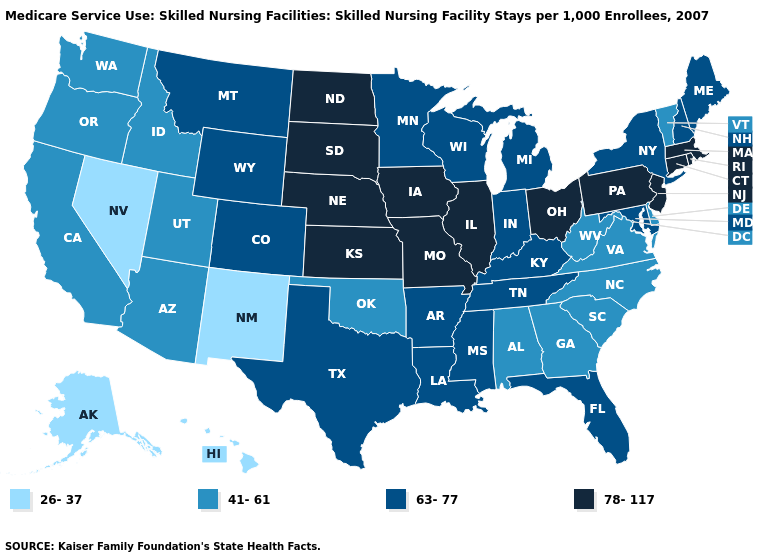Name the states that have a value in the range 41-61?
Short answer required. Alabama, Arizona, California, Delaware, Georgia, Idaho, North Carolina, Oklahoma, Oregon, South Carolina, Utah, Vermont, Virginia, Washington, West Virginia. Name the states that have a value in the range 63-77?
Keep it brief. Arkansas, Colorado, Florida, Indiana, Kentucky, Louisiana, Maine, Maryland, Michigan, Minnesota, Mississippi, Montana, New Hampshire, New York, Tennessee, Texas, Wisconsin, Wyoming. What is the highest value in the South ?
Quick response, please. 63-77. What is the value of Oklahoma?
Answer briefly. 41-61. Name the states that have a value in the range 41-61?
Quick response, please. Alabama, Arizona, California, Delaware, Georgia, Idaho, North Carolina, Oklahoma, Oregon, South Carolina, Utah, Vermont, Virginia, Washington, West Virginia. Does Texas have the same value as Tennessee?
Give a very brief answer. Yes. Name the states that have a value in the range 63-77?
Short answer required. Arkansas, Colorado, Florida, Indiana, Kentucky, Louisiana, Maine, Maryland, Michigan, Minnesota, Mississippi, Montana, New Hampshire, New York, Tennessee, Texas, Wisconsin, Wyoming. Name the states that have a value in the range 63-77?
Keep it brief. Arkansas, Colorado, Florida, Indiana, Kentucky, Louisiana, Maine, Maryland, Michigan, Minnesota, Mississippi, Montana, New Hampshire, New York, Tennessee, Texas, Wisconsin, Wyoming. What is the value of Michigan?
Concise answer only. 63-77. Name the states that have a value in the range 26-37?
Keep it brief. Alaska, Hawaii, Nevada, New Mexico. What is the highest value in states that border Arizona?
Write a very short answer. 63-77. Does Minnesota have the lowest value in the MidWest?
Be succinct. Yes. Among the states that border Massachusetts , which have the lowest value?
Concise answer only. Vermont. Does Nebraska have the highest value in the USA?
Give a very brief answer. Yes. What is the highest value in states that border Oregon?
Quick response, please. 41-61. 